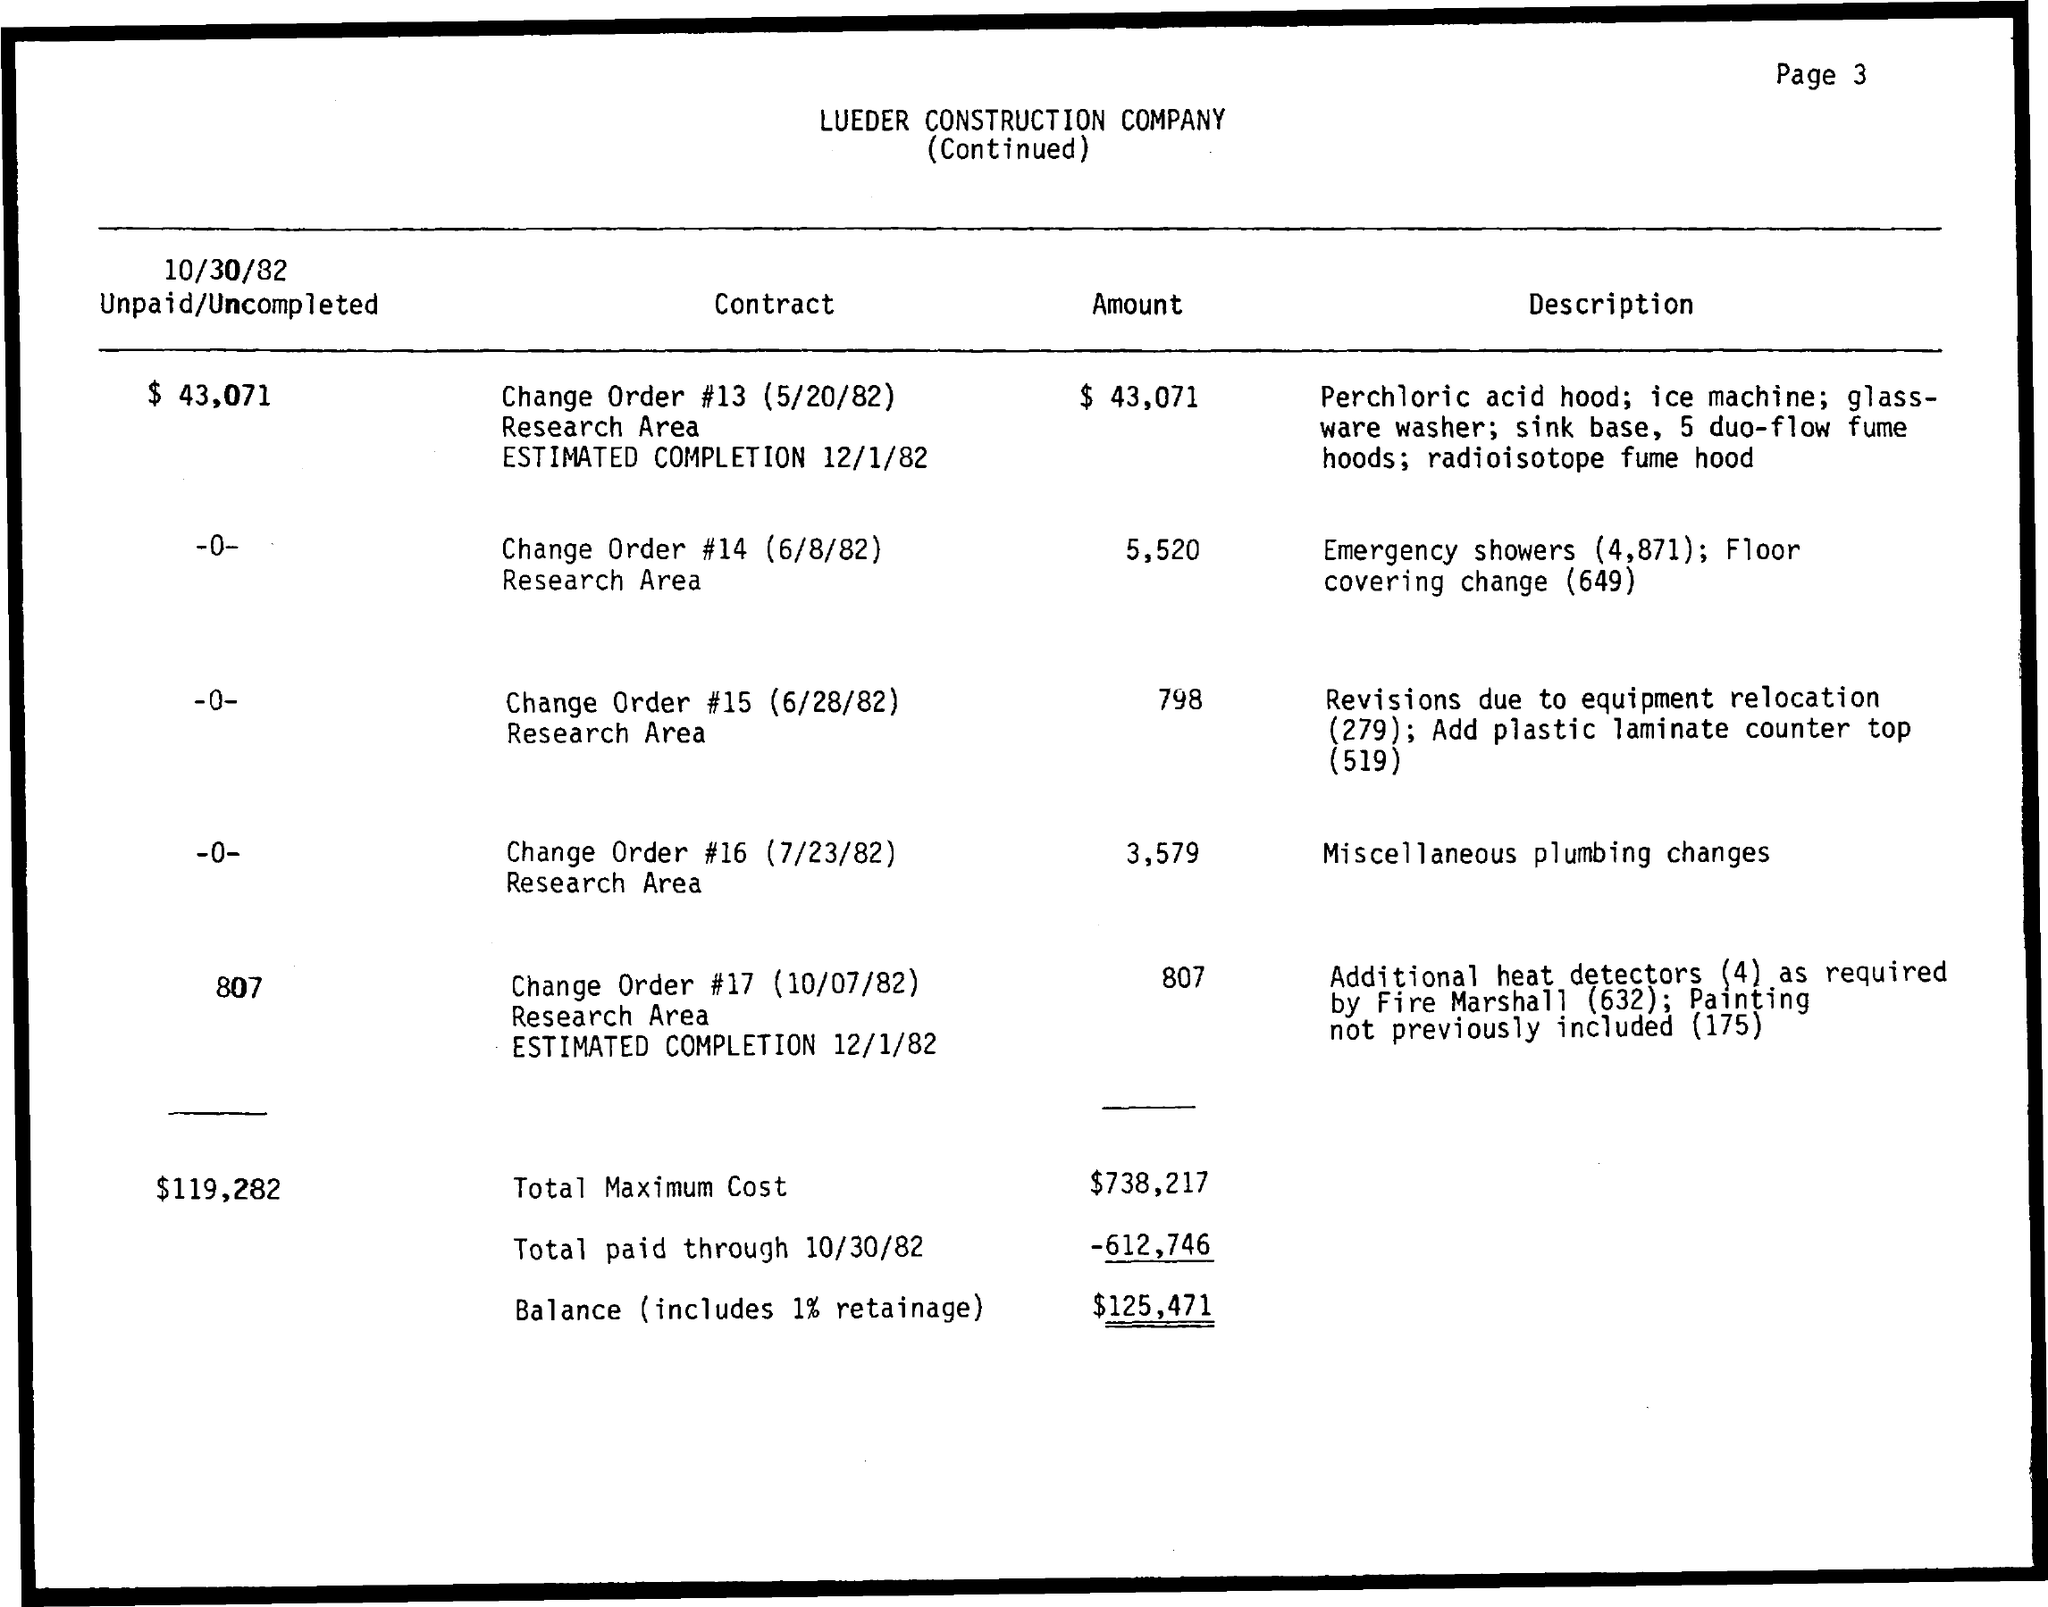Outline some significant characteristics in this image. The total maximum cost is $738,217. 